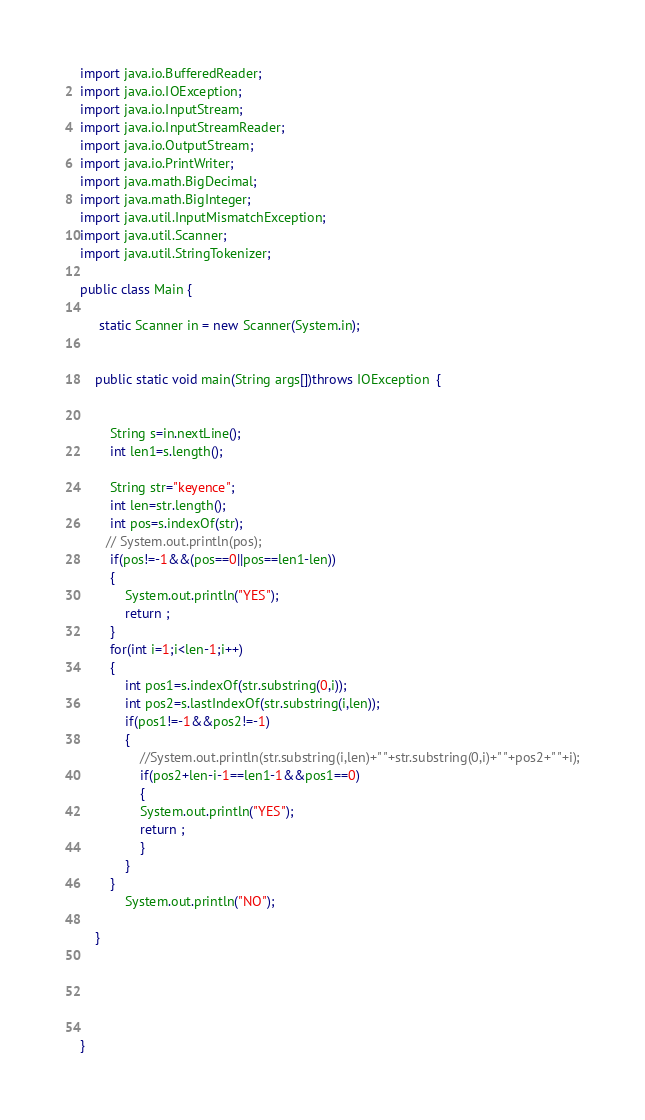<code> <loc_0><loc_0><loc_500><loc_500><_Java_>import java.io.BufferedReader;
import java.io.IOException;
import java.io.InputStream;
import java.io.InputStreamReader;
import java.io.OutputStream;
import java.io.PrintWriter;
import java.math.BigDecimal;
import java.math.BigInteger;
import java.util.InputMismatchException;
import java.util.Scanner;
import java.util.StringTokenizer;

public class Main {
	
	 static Scanner in = new Scanner(System.in);
	 
   
	public static void main(String args[])throws IOException  {
   
    	
        String s=in.nextLine(); 
        int len1=s.length();
       
        String str="keyence";
        int len=str.length();
        int pos=s.indexOf(str);
       // System.out.println(pos);
        if(pos!=-1&&(pos==0||pos==len1-len))
        {
    		System.out.println("YES");
    		return ;
    	}
        for(int i=1;i<len-1;i++)
        {
        	int pos1=s.indexOf(str.substring(0,i));
        	int pos2=s.lastIndexOf(str.substring(i,len));
        	if(pos1!=-1&&pos2!=-1)
        	{
        		//System.out.println(str.substring(i,len)+" "+str.substring(0,i)+" "+pos2+" "+i);
        		if(pos2+len-i-1==len1-1&&pos1==0)
        		{
        		System.out.println("YES");
        		return ;
        		}
        	}
        }
    		System.out.println("NO");	
     	
    }

	
	
 
	
}</code> 